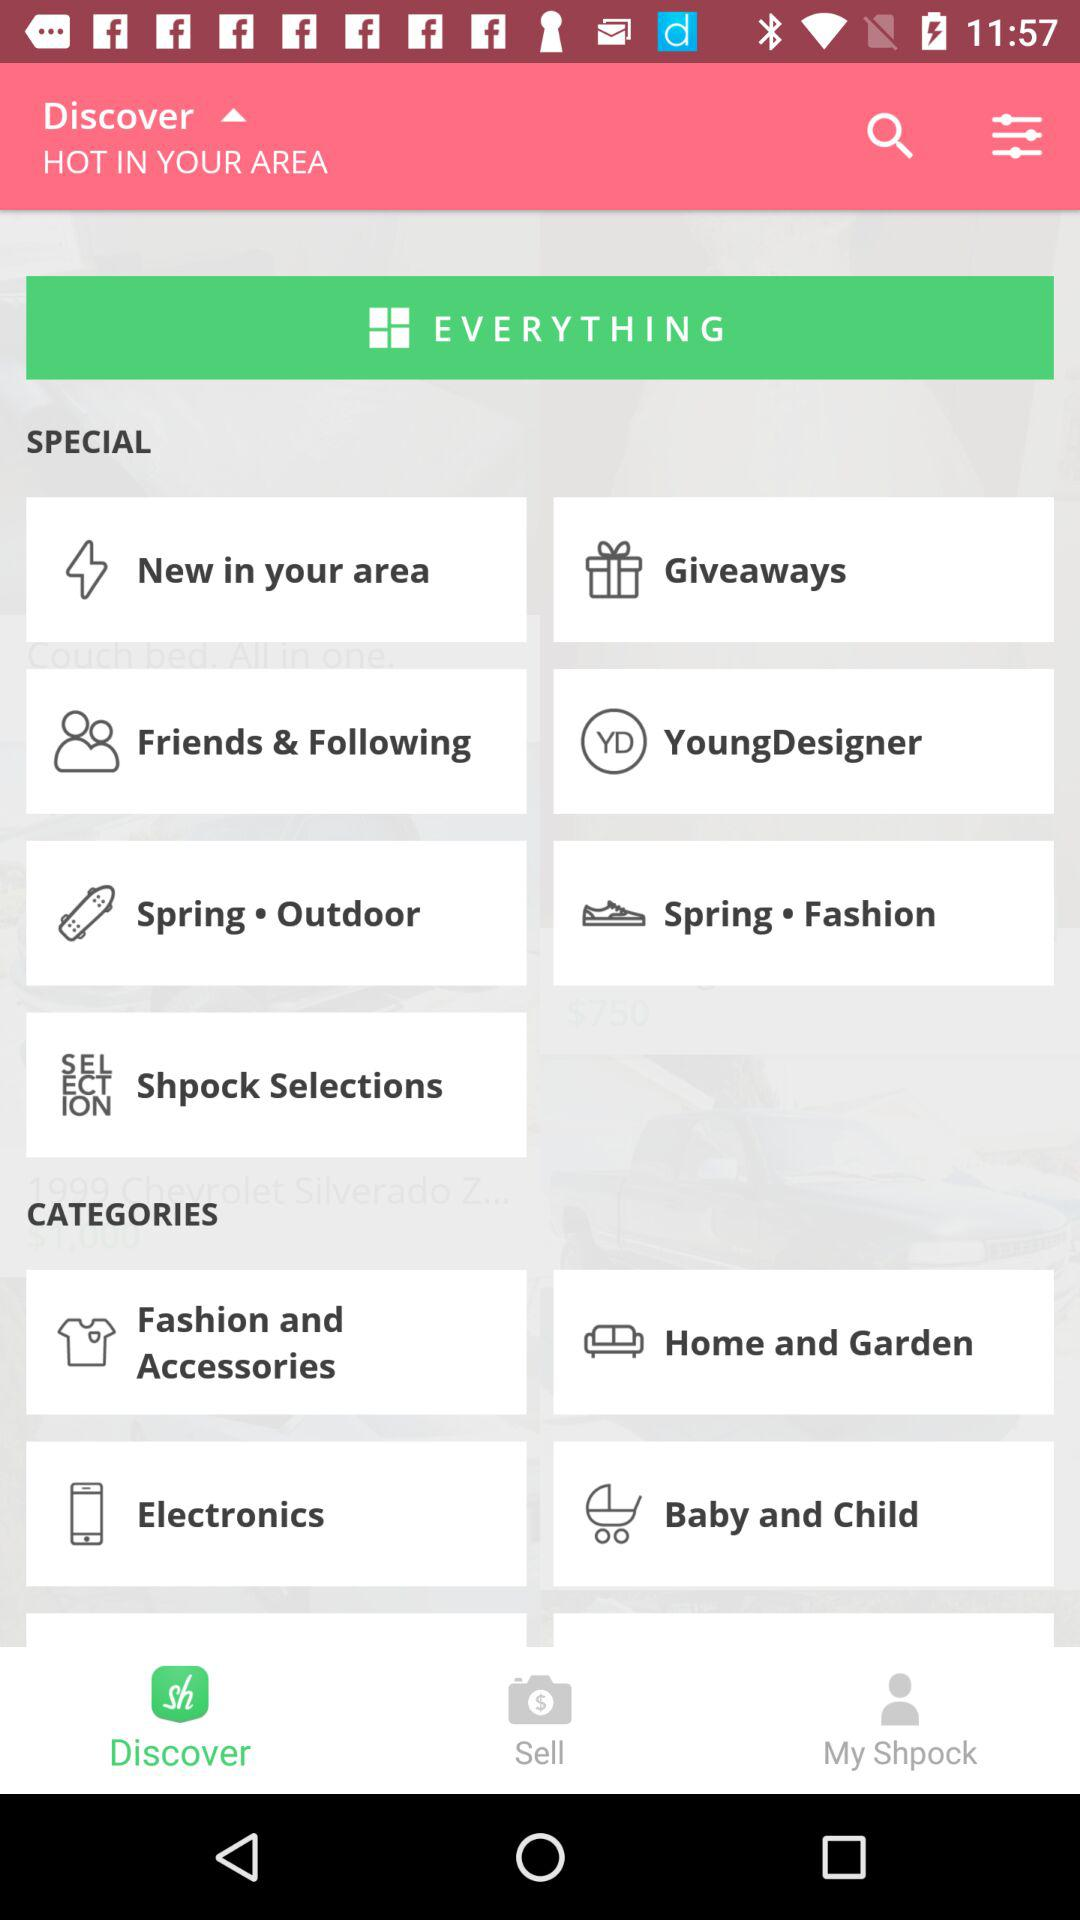Which tab is selected? The selected tab is "Discover". 